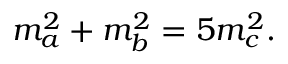<formula> <loc_0><loc_0><loc_500><loc_500>m _ { a } ^ { 2 } + m _ { b } ^ { 2 } = 5 m _ { c } ^ { 2 } .</formula> 